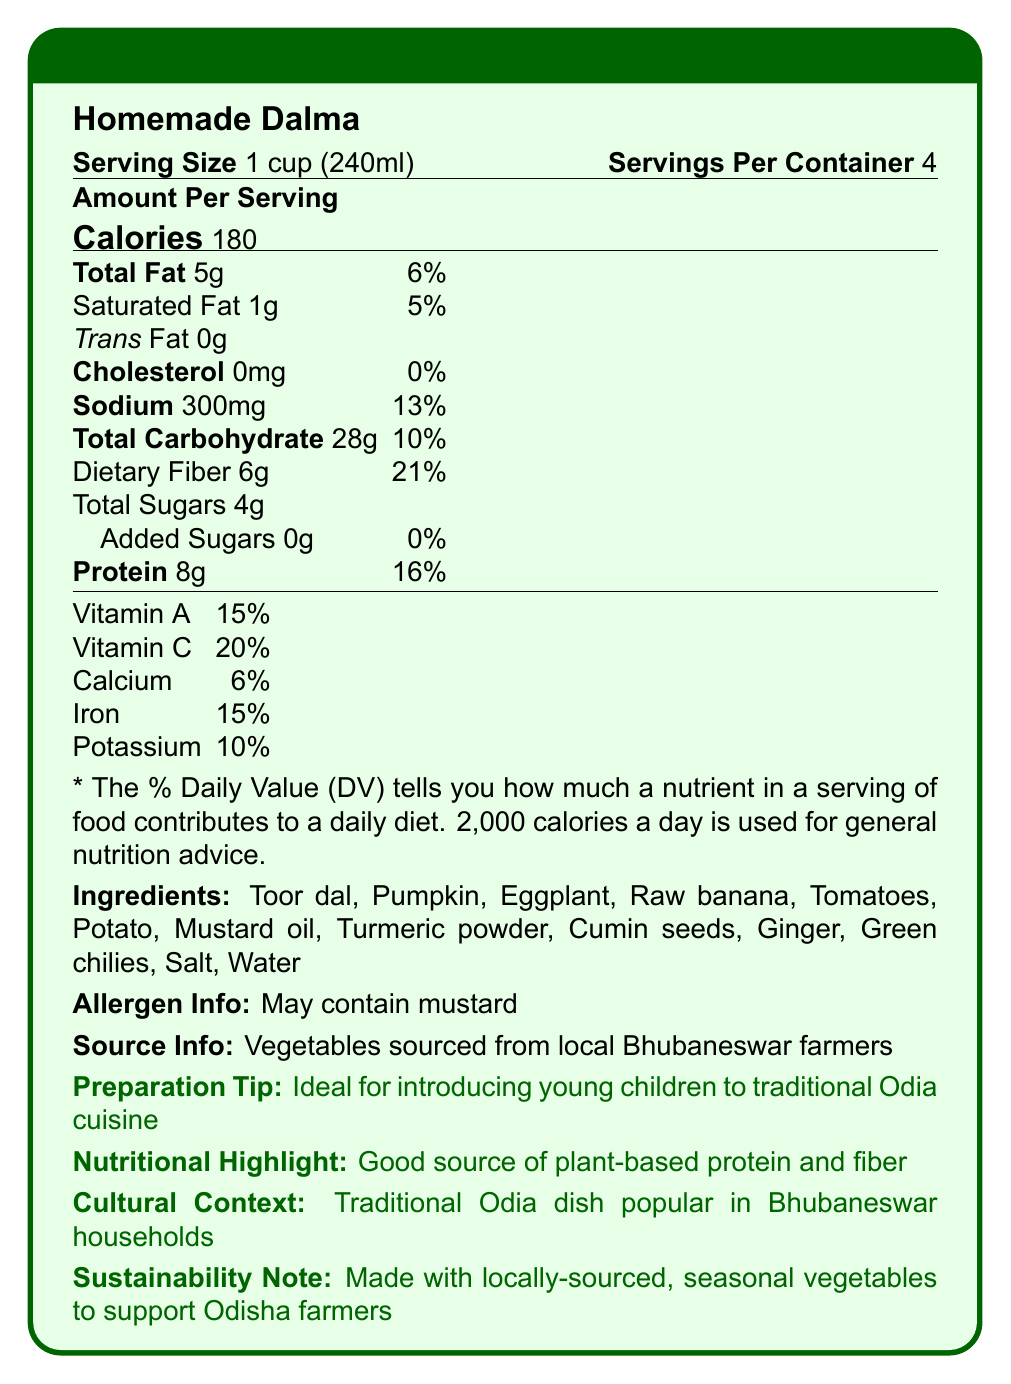what is the serving size for Homemade Dalma? The document specifies that the serving size is 1 cup (240ml).
Answer: 1 cup (240ml) how many servings are in one container? The document mentions that the number of servings per container is 4.
Answer: 4 how much protein does one serving of Homemade Dalma provide? The nutrition facts state that the amount of protein per serving is 8g.
Answer: 8g what is the percentage daily value of dietary fiber in one serving? The document illustrates that the daily value of dietary fiber per serving is 21%.
Answer: 21% what are the main ingredients in Homemade Dalma? The document lists these items under the "Ingredients" section.
Answer: Toor dal, Pumpkin, Eggplant, Raw banana, Tomatoes, Potato, Mustard oil, Turmeric powder, Cumin seeds, Ginger, Green chilies, Salt, Water what is the cultural significance of Homemade Dalma mentioned in the document? The document highlights that it is a traditional Odia dish popular in Bhubaneswar households.
Answer: Traditional Odia dish popular in Bhubaneswar households how much sodium is there in one serving? The document shows that the amount of sodium per serving is 300mg.
Answer: 300mg what is the calorie count of one serving of Homemade Dalma? The document mentions that the calories per serving are 180.
Answer: 180 what is the added sugars content in one serving? The nutrition facts label shows that the added sugars per serving is 0g.
Answer: 0g how is Homemade Dalma beneficial for young children as stated in the document? The document suggests that Homemade Dalma is ideal for introducing young children to traditional Odia cuisine.
Answer: Ideal for introducing young children to traditional Odia cuisine what are the different items contributing to the fat content in Homemade Dalma? A. Mustard oil B. Butter C. Coconut oil The document lists Mustard oil as an ingredient, while butter and coconut oil are not mentioned.
Answer: A. Mustard oil how much iron does one serving of Homemade Dalma provide? A. 6% B. 10% C. 15% The document states that iron contributes 15% of the daily value per serving.
Answer: C. 15% is Homemade Dalma free from cholesterol? The nutrition facts label shows that the cholesterol content is 0mg, meaning it is cholesterol-free.
Answer: Yes does the document specify the preparation method of Homemade Dalma? The document does not provide any detailed preparation method; it only gives a preparation tip.
Answer: Cannot be determined describe the main idea of the document in one or two sentences. The document serves as a comprehensive overview of Homemade Dalma's nutritional profile, emphasizing its health benefits and cultural importance.
Answer: The document provides the nutritional facts label for Homemade Dalma, highlighting its protein and fiber content, serving size, servings per container, and the percentage daily values of various nutrients. It includes ingredient details, source information, and emphasizes the dish's cultural and nutritional significance. 